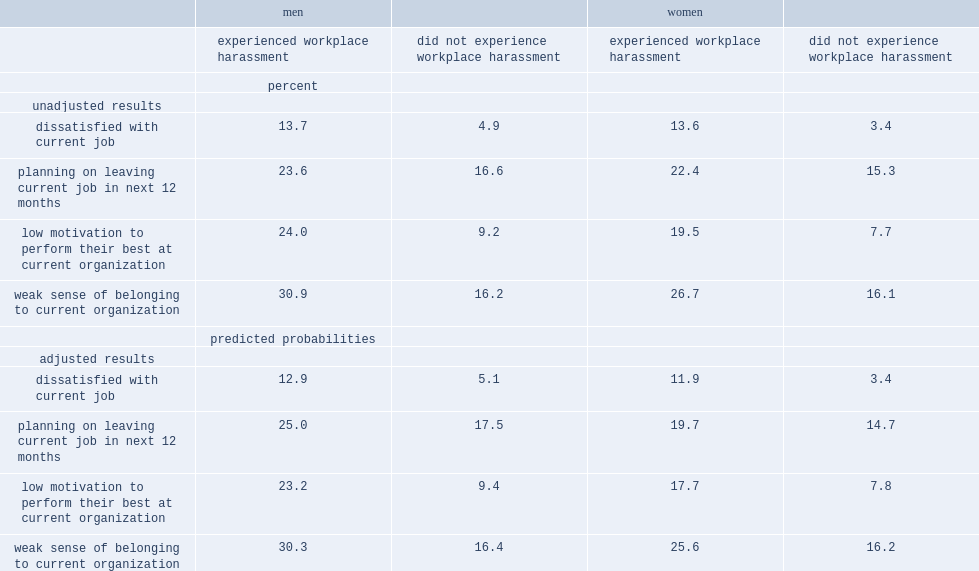What was the percentage of women who had experienced harassment dissatisfied with their current job. 13.6. What was the percentage of men who had experienced harassment dissatisfied with their current job? 13.7. What was the percentage of men who had experienced harassment had low motivation to perform their best at their current organization? 24.0. What was the percentage of women who had experienced harassment had low motivation to perform their best at their current organization? 19.5. 